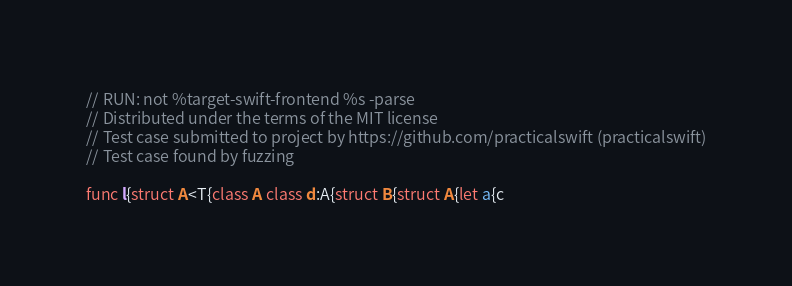Convert code to text. <code><loc_0><loc_0><loc_500><loc_500><_Swift_>// RUN: not %target-swift-frontend %s -parse
// Distributed under the terms of the MIT license
// Test case submitted to project by https://github.com/practicalswift (practicalswift)
// Test case found by fuzzing

func l{struct A<T{class A class d:A{struct B{struct A{let a{c
</code> 